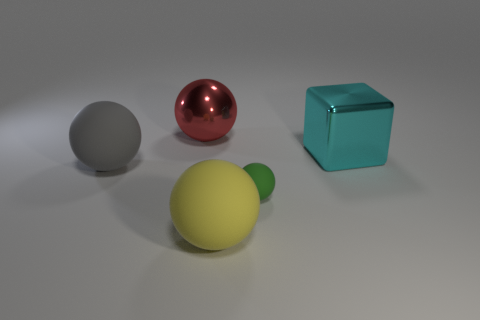What number of objects are things behind the yellow matte object or green rubber balls?
Provide a succinct answer. 4. There is a cyan object that is made of the same material as the red sphere; what is its size?
Offer a very short reply. Large. Is the size of the green ball the same as the shiny thing that is on the left side of the yellow rubber thing?
Ensure brevity in your answer.  No. What is the color of the object that is both right of the large yellow rubber thing and on the left side of the large cyan thing?
Provide a short and direct response. Green. What number of objects are metallic objects that are to the right of the large yellow ball or large balls in front of the cyan cube?
Give a very brief answer. 3. What color is the large matte ball right of the object that is behind the metal object that is right of the tiny green sphere?
Offer a terse response. Yellow. Are there any green rubber objects that have the same shape as the large red object?
Your response must be concise. Yes. What number of large spheres are there?
Provide a succinct answer. 3. There is a tiny matte object; what shape is it?
Your answer should be very brief. Sphere. What number of metallic balls are the same size as the green object?
Your answer should be compact. 0. 